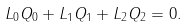Convert formula to latex. <formula><loc_0><loc_0><loc_500><loc_500>L _ { 0 } Q _ { 0 } + L _ { 1 } Q _ { 1 } + L _ { 2 } Q _ { 2 } = 0 .</formula> 